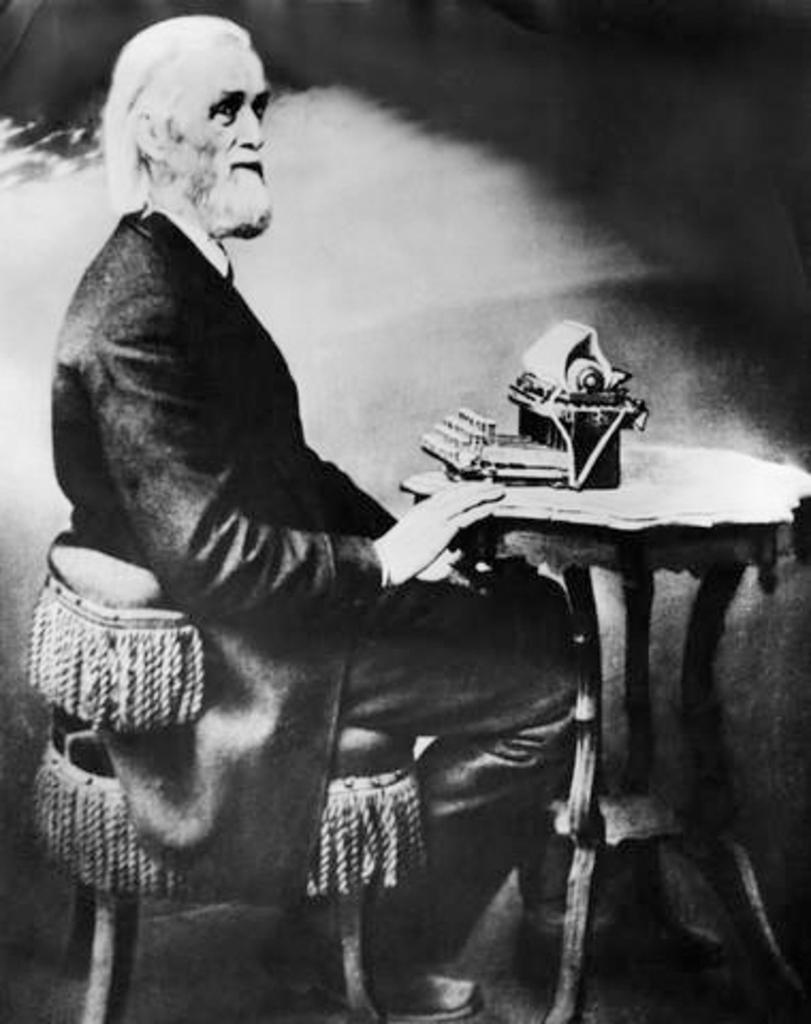What is the color scheme of the image? The image is black and white. Who is present in the image? There is a man in the image. What is the man doing in the image? The man is sitting on a chair. Where is the chair located in relation to the table? The chair is near a table. What can be found on the table in the image? There is an object on the table. What type of cushion is the goat sitting on in the image? There is no goat present in the image, and therefore no cushion for it to sit on. 